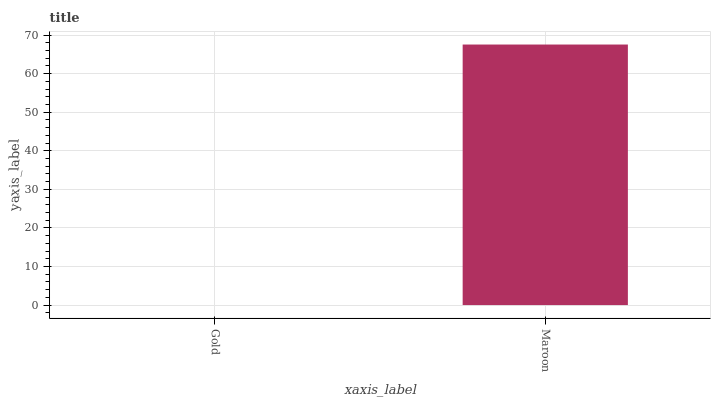Is Gold the minimum?
Answer yes or no. Yes. Is Maroon the maximum?
Answer yes or no. Yes. Is Maroon the minimum?
Answer yes or no. No. Is Maroon greater than Gold?
Answer yes or no. Yes. Is Gold less than Maroon?
Answer yes or no. Yes. Is Gold greater than Maroon?
Answer yes or no. No. Is Maroon less than Gold?
Answer yes or no. No. Is Maroon the high median?
Answer yes or no. Yes. Is Gold the low median?
Answer yes or no. Yes. Is Gold the high median?
Answer yes or no. No. Is Maroon the low median?
Answer yes or no. No. 